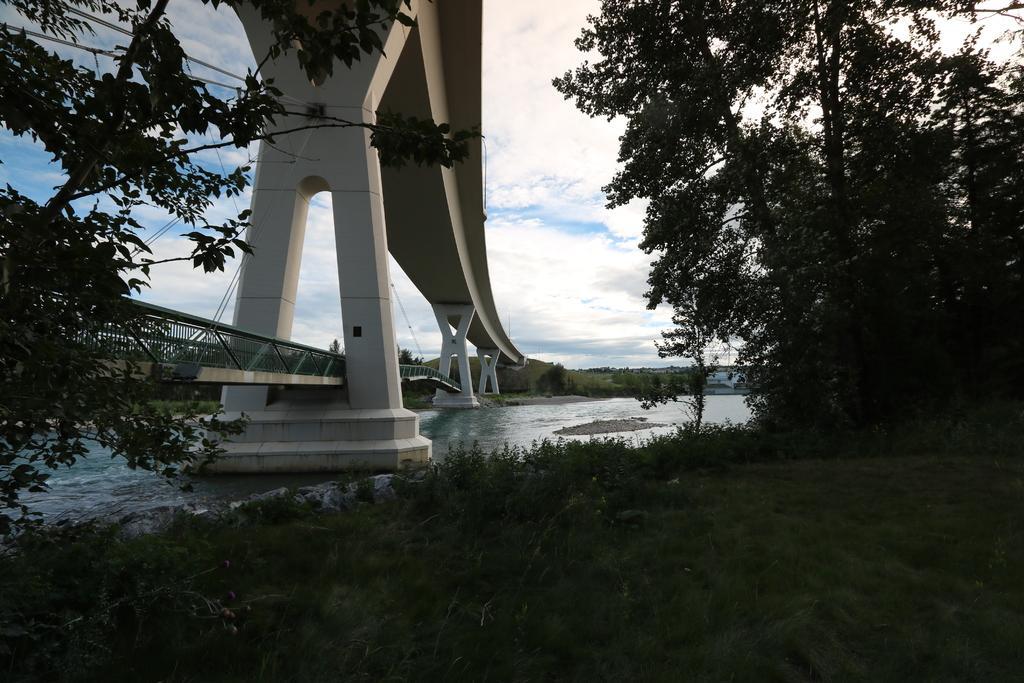Please provide a concise description of this image. In this image, on the right side, we can see some trees and plants. On the left side, we can see some trees, plants, bridge, pillars, rope. In the background, we can see some trees, plants. At the top, we can see a sky which is a bit cloudy, at the bottom, we can see water in a lake and a grass. 